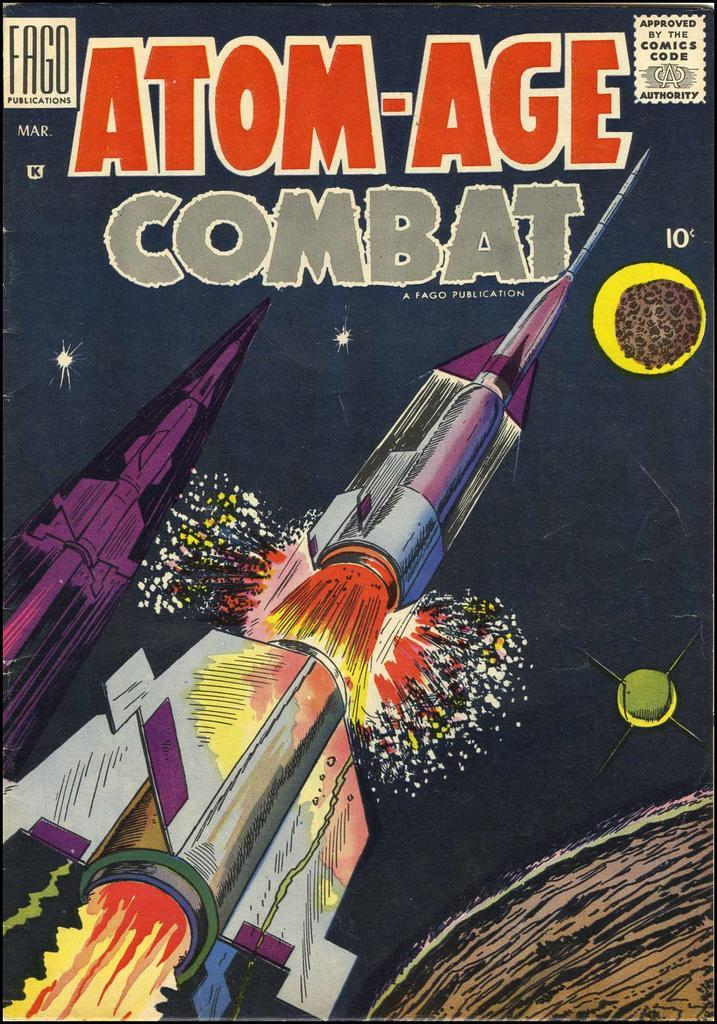<image>
Relay a brief, clear account of the picture shown. A comic book atom-age combat with a rocket on the cover. 